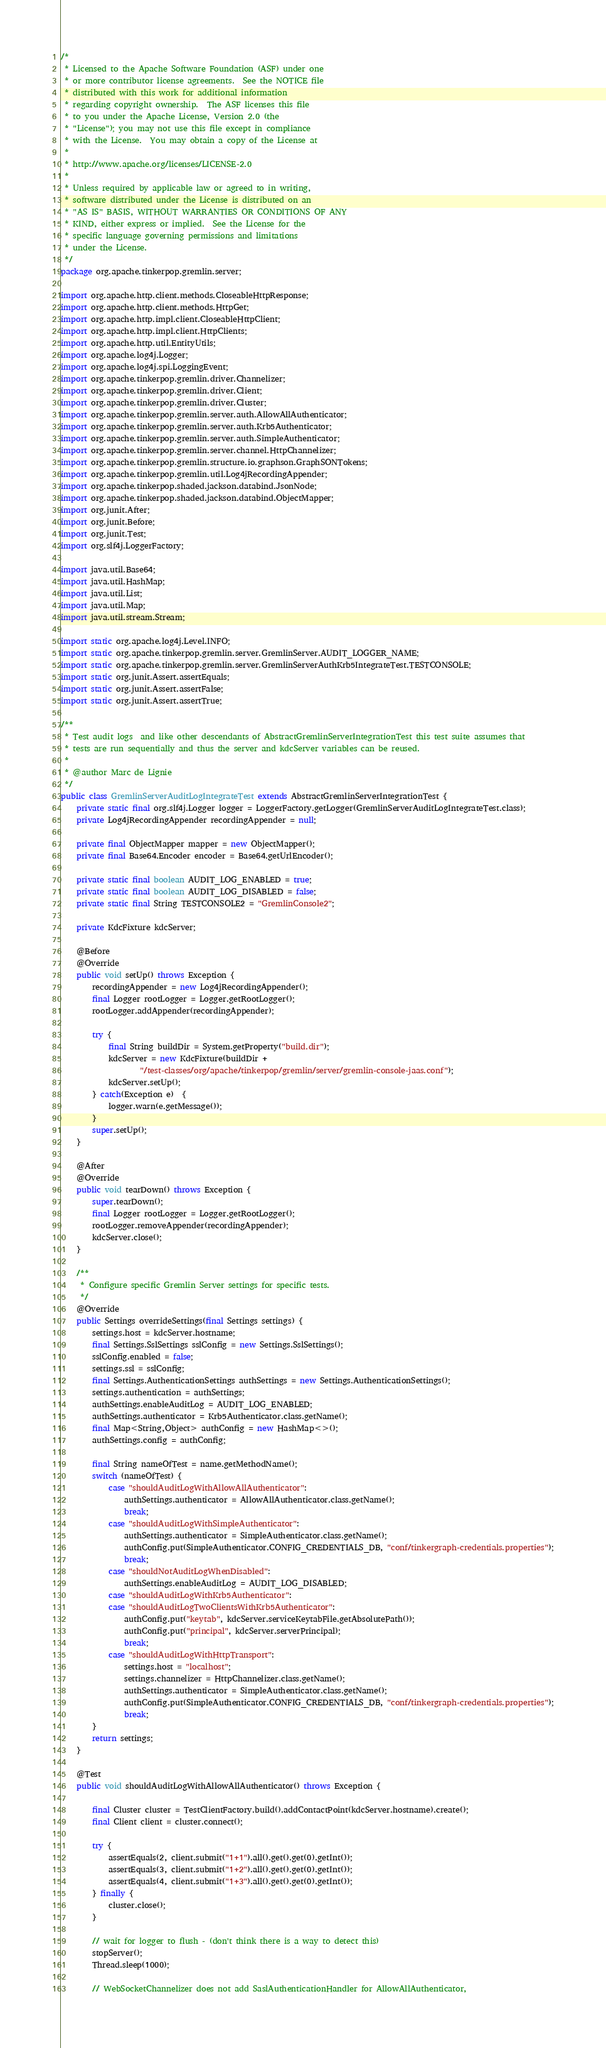Convert code to text. <code><loc_0><loc_0><loc_500><loc_500><_Java_>/*
 * Licensed to the Apache Software Foundation (ASF) under one
 * or more contributor license agreements.  See the NOTICE file
 * distributed with this work for additional information
 * regarding copyright ownership.  The ASF licenses this file
 * to you under the Apache License, Version 2.0 (the
 * "License"); you may not use this file except in compliance
 * with the License.  You may obtain a copy of the License at
 *
 * http://www.apache.org/licenses/LICENSE-2.0
 *
 * Unless required by applicable law or agreed to in writing,
 * software distributed under the License is distributed on an
 * "AS IS" BASIS, WITHOUT WARRANTIES OR CONDITIONS OF ANY
 * KIND, either express or implied.  See the License for the
 * specific language governing permissions and limitations
 * under the License.
 */
package org.apache.tinkerpop.gremlin.server;

import org.apache.http.client.methods.CloseableHttpResponse;
import org.apache.http.client.methods.HttpGet;
import org.apache.http.impl.client.CloseableHttpClient;
import org.apache.http.impl.client.HttpClients;
import org.apache.http.util.EntityUtils;
import org.apache.log4j.Logger;
import org.apache.log4j.spi.LoggingEvent;
import org.apache.tinkerpop.gremlin.driver.Channelizer;
import org.apache.tinkerpop.gremlin.driver.Client;
import org.apache.tinkerpop.gremlin.driver.Cluster;
import org.apache.tinkerpop.gremlin.server.auth.AllowAllAuthenticator;
import org.apache.tinkerpop.gremlin.server.auth.Krb5Authenticator;
import org.apache.tinkerpop.gremlin.server.auth.SimpleAuthenticator;
import org.apache.tinkerpop.gremlin.server.channel.HttpChannelizer;
import org.apache.tinkerpop.gremlin.structure.io.graphson.GraphSONTokens;
import org.apache.tinkerpop.gremlin.util.Log4jRecordingAppender;
import org.apache.tinkerpop.shaded.jackson.databind.JsonNode;
import org.apache.tinkerpop.shaded.jackson.databind.ObjectMapper;
import org.junit.After;
import org.junit.Before;
import org.junit.Test;
import org.slf4j.LoggerFactory;

import java.util.Base64;
import java.util.HashMap;
import java.util.List;
import java.util.Map;
import java.util.stream.Stream;

import static org.apache.log4j.Level.INFO;
import static org.apache.tinkerpop.gremlin.server.GremlinServer.AUDIT_LOGGER_NAME;
import static org.apache.tinkerpop.gremlin.server.GremlinServerAuthKrb5IntegrateTest.TESTCONSOLE;
import static org.junit.Assert.assertEquals;
import static org.junit.Assert.assertFalse;
import static org.junit.Assert.assertTrue;

/**
 * Test audit logs  and like other descendants of AbstractGremlinServerIntegrationTest this test suite assumes that
 * tests are run sequentially and thus the server and kdcServer variables can be reused.
 *
 * @author Marc de Lignie
 */
public class GremlinServerAuditLogIntegrateTest extends AbstractGremlinServerIntegrationTest {
    private static final org.slf4j.Logger logger = LoggerFactory.getLogger(GremlinServerAuditLogIntegrateTest.class);
    private Log4jRecordingAppender recordingAppender = null;

    private final ObjectMapper mapper = new ObjectMapper();
    private final Base64.Encoder encoder = Base64.getUrlEncoder();

    private static final boolean AUDIT_LOG_ENABLED = true;
    private static final boolean AUDIT_LOG_DISABLED = false;
    private static final String TESTCONSOLE2 = "GremlinConsole2";

    private KdcFixture kdcServer;

    @Before
    @Override
    public void setUp() throws Exception {
        recordingAppender = new Log4jRecordingAppender();
        final Logger rootLogger = Logger.getRootLogger();
        rootLogger.addAppender(recordingAppender);

        try {
            final String buildDir = System.getProperty("build.dir");
            kdcServer = new KdcFixture(buildDir +
                    "/test-classes/org/apache/tinkerpop/gremlin/server/gremlin-console-jaas.conf");
            kdcServer.setUp();
        } catch(Exception e)  {
            logger.warn(e.getMessage());
        }
        super.setUp();
    }

    @After
    @Override
    public void tearDown() throws Exception {
        super.tearDown();
        final Logger rootLogger = Logger.getRootLogger();
        rootLogger.removeAppender(recordingAppender);
        kdcServer.close();
    }

    /**
     * Configure specific Gremlin Server settings for specific tests.
     */
    @Override
    public Settings overrideSettings(final Settings settings) {
        settings.host = kdcServer.hostname;
        final Settings.SslSettings sslConfig = new Settings.SslSettings();
        sslConfig.enabled = false;
        settings.ssl = sslConfig;
        final Settings.AuthenticationSettings authSettings = new Settings.AuthenticationSettings();
        settings.authentication = authSettings;
        authSettings.enableAuditLog = AUDIT_LOG_ENABLED;
        authSettings.authenticator = Krb5Authenticator.class.getName();
        final Map<String,Object> authConfig = new HashMap<>();
        authSettings.config = authConfig;

        final String nameOfTest = name.getMethodName();
        switch (nameOfTest) {
            case "shouldAuditLogWithAllowAllAuthenticator":
                authSettings.authenticator = AllowAllAuthenticator.class.getName();
                break;
            case "shouldAuditLogWithSimpleAuthenticator":
                authSettings.authenticator = SimpleAuthenticator.class.getName();
                authConfig.put(SimpleAuthenticator.CONFIG_CREDENTIALS_DB, "conf/tinkergraph-credentials.properties");
                break;
            case "shouldNotAuditLogWhenDisabled":
                authSettings.enableAuditLog = AUDIT_LOG_DISABLED;
            case "shouldAuditLogWithKrb5Authenticator":
            case "shouldAuditLogTwoClientsWithKrb5Authenticator":
                authConfig.put("keytab", kdcServer.serviceKeytabFile.getAbsolutePath());
                authConfig.put("principal", kdcServer.serverPrincipal);
                break;
            case "shouldAuditLogWithHttpTransport":
                settings.host = "localhost";
                settings.channelizer = HttpChannelizer.class.getName();
                authSettings.authenticator = SimpleAuthenticator.class.getName();
                authConfig.put(SimpleAuthenticator.CONFIG_CREDENTIALS_DB, "conf/tinkergraph-credentials.properties");
                break;
        }
        return settings;
    }

    @Test
    public void shouldAuditLogWithAllowAllAuthenticator() throws Exception {

        final Cluster cluster = TestClientFactory.build().addContactPoint(kdcServer.hostname).create();
        final Client client = cluster.connect();

        try {
            assertEquals(2, client.submit("1+1").all().get().get(0).getInt());
            assertEquals(3, client.submit("1+2").all().get().get(0).getInt());
            assertEquals(4, client.submit("1+3").all().get().get(0).getInt());
        } finally {
            cluster.close();
        }

        // wait for logger to flush - (don't think there is a way to detect this)
        stopServer();
        Thread.sleep(1000);

        // WebSocketChannelizer does not add SaslAuthenticationHandler for AllowAllAuthenticator,</code> 